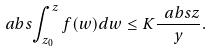<formula> <loc_0><loc_0><loc_500><loc_500>\ a b s { \int _ { z _ { 0 } } ^ { z } f ( w ) d w } \leq K \frac { \ a b s { z } } { y } .</formula> 